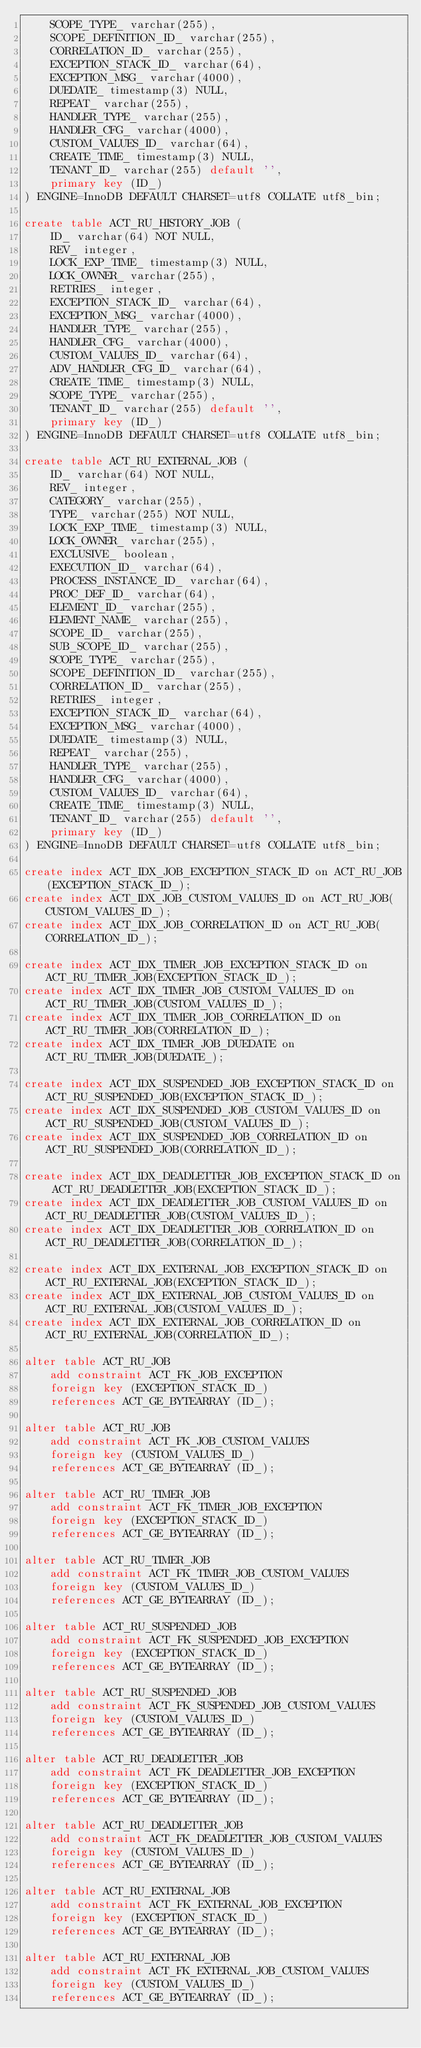Convert code to text. <code><loc_0><loc_0><loc_500><loc_500><_SQL_>    SCOPE_TYPE_ varchar(255),
    SCOPE_DEFINITION_ID_ varchar(255),
    CORRELATION_ID_ varchar(255),
    EXCEPTION_STACK_ID_ varchar(64),
    EXCEPTION_MSG_ varchar(4000),
    DUEDATE_ timestamp(3) NULL,
    REPEAT_ varchar(255),
    HANDLER_TYPE_ varchar(255),
    HANDLER_CFG_ varchar(4000),
    CUSTOM_VALUES_ID_ varchar(64),
    CREATE_TIME_ timestamp(3) NULL,
    TENANT_ID_ varchar(255) default '',
    primary key (ID_)
) ENGINE=InnoDB DEFAULT CHARSET=utf8 COLLATE utf8_bin;

create table ACT_RU_HISTORY_JOB (
    ID_ varchar(64) NOT NULL,
    REV_ integer,
    LOCK_EXP_TIME_ timestamp(3) NULL,
    LOCK_OWNER_ varchar(255),
    RETRIES_ integer,
    EXCEPTION_STACK_ID_ varchar(64),
    EXCEPTION_MSG_ varchar(4000),
    HANDLER_TYPE_ varchar(255),
    HANDLER_CFG_ varchar(4000),
    CUSTOM_VALUES_ID_ varchar(64),
    ADV_HANDLER_CFG_ID_ varchar(64),
    CREATE_TIME_ timestamp(3) NULL,
    SCOPE_TYPE_ varchar(255),
    TENANT_ID_ varchar(255) default '',
    primary key (ID_)
) ENGINE=InnoDB DEFAULT CHARSET=utf8 COLLATE utf8_bin;

create table ACT_RU_EXTERNAL_JOB (
    ID_ varchar(64) NOT NULL,
    REV_ integer,
    CATEGORY_ varchar(255),
    TYPE_ varchar(255) NOT NULL,
    LOCK_EXP_TIME_ timestamp(3) NULL,
    LOCK_OWNER_ varchar(255),
    EXCLUSIVE_ boolean,
    EXECUTION_ID_ varchar(64),
    PROCESS_INSTANCE_ID_ varchar(64),
    PROC_DEF_ID_ varchar(64),
    ELEMENT_ID_ varchar(255),
    ELEMENT_NAME_ varchar(255),
    SCOPE_ID_ varchar(255),
    SUB_SCOPE_ID_ varchar(255),
    SCOPE_TYPE_ varchar(255),
    SCOPE_DEFINITION_ID_ varchar(255),
    CORRELATION_ID_ varchar(255),
    RETRIES_ integer,
    EXCEPTION_STACK_ID_ varchar(64),
    EXCEPTION_MSG_ varchar(4000),
    DUEDATE_ timestamp(3) NULL,
    REPEAT_ varchar(255),
    HANDLER_TYPE_ varchar(255),
    HANDLER_CFG_ varchar(4000),
    CUSTOM_VALUES_ID_ varchar(64),
    CREATE_TIME_ timestamp(3) NULL,
    TENANT_ID_ varchar(255) default '',
    primary key (ID_)
) ENGINE=InnoDB DEFAULT CHARSET=utf8 COLLATE utf8_bin;

create index ACT_IDX_JOB_EXCEPTION_STACK_ID on ACT_RU_JOB(EXCEPTION_STACK_ID_);
create index ACT_IDX_JOB_CUSTOM_VALUES_ID on ACT_RU_JOB(CUSTOM_VALUES_ID_);
create index ACT_IDX_JOB_CORRELATION_ID on ACT_RU_JOB(CORRELATION_ID_);

create index ACT_IDX_TIMER_JOB_EXCEPTION_STACK_ID on ACT_RU_TIMER_JOB(EXCEPTION_STACK_ID_);
create index ACT_IDX_TIMER_JOB_CUSTOM_VALUES_ID on ACT_RU_TIMER_JOB(CUSTOM_VALUES_ID_);
create index ACT_IDX_TIMER_JOB_CORRELATION_ID on ACT_RU_TIMER_JOB(CORRELATION_ID_);
create index ACT_IDX_TIMER_JOB_DUEDATE on ACT_RU_TIMER_JOB(DUEDATE_); 

create index ACT_IDX_SUSPENDED_JOB_EXCEPTION_STACK_ID on ACT_RU_SUSPENDED_JOB(EXCEPTION_STACK_ID_);
create index ACT_IDX_SUSPENDED_JOB_CUSTOM_VALUES_ID on ACT_RU_SUSPENDED_JOB(CUSTOM_VALUES_ID_);
create index ACT_IDX_SUSPENDED_JOB_CORRELATION_ID on ACT_RU_SUSPENDED_JOB(CORRELATION_ID_);

create index ACT_IDX_DEADLETTER_JOB_EXCEPTION_STACK_ID on ACT_RU_DEADLETTER_JOB(EXCEPTION_STACK_ID_);
create index ACT_IDX_DEADLETTER_JOB_CUSTOM_VALUES_ID on ACT_RU_DEADLETTER_JOB(CUSTOM_VALUES_ID_);
create index ACT_IDX_DEADLETTER_JOB_CORRELATION_ID on ACT_RU_DEADLETTER_JOB(CORRELATION_ID_);

create index ACT_IDX_EXTERNAL_JOB_EXCEPTION_STACK_ID on ACT_RU_EXTERNAL_JOB(EXCEPTION_STACK_ID_);
create index ACT_IDX_EXTERNAL_JOB_CUSTOM_VALUES_ID on ACT_RU_EXTERNAL_JOB(CUSTOM_VALUES_ID_);
create index ACT_IDX_EXTERNAL_JOB_CORRELATION_ID on ACT_RU_EXTERNAL_JOB(CORRELATION_ID_);

alter table ACT_RU_JOB
    add constraint ACT_FK_JOB_EXCEPTION
    foreign key (EXCEPTION_STACK_ID_)
    references ACT_GE_BYTEARRAY (ID_);

alter table ACT_RU_JOB
    add constraint ACT_FK_JOB_CUSTOM_VALUES
    foreign key (CUSTOM_VALUES_ID_)
    references ACT_GE_BYTEARRAY (ID_);

alter table ACT_RU_TIMER_JOB
    add constraint ACT_FK_TIMER_JOB_EXCEPTION
    foreign key (EXCEPTION_STACK_ID_)
    references ACT_GE_BYTEARRAY (ID_);

alter table ACT_RU_TIMER_JOB
    add constraint ACT_FK_TIMER_JOB_CUSTOM_VALUES
    foreign key (CUSTOM_VALUES_ID_)
    references ACT_GE_BYTEARRAY (ID_);

alter table ACT_RU_SUSPENDED_JOB
    add constraint ACT_FK_SUSPENDED_JOB_EXCEPTION
    foreign key (EXCEPTION_STACK_ID_)
    references ACT_GE_BYTEARRAY (ID_);

alter table ACT_RU_SUSPENDED_JOB
    add constraint ACT_FK_SUSPENDED_JOB_CUSTOM_VALUES
    foreign key (CUSTOM_VALUES_ID_)
    references ACT_GE_BYTEARRAY (ID_);

alter table ACT_RU_DEADLETTER_JOB
    add constraint ACT_FK_DEADLETTER_JOB_EXCEPTION
    foreign key (EXCEPTION_STACK_ID_)
    references ACT_GE_BYTEARRAY (ID_);

alter table ACT_RU_DEADLETTER_JOB
    add constraint ACT_FK_DEADLETTER_JOB_CUSTOM_VALUES
    foreign key (CUSTOM_VALUES_ID_)
    references ACT_GE_BYTEARRAY (ID_);

alter table ACT_RU_EXTERNAL_JOB
    add constraint ACT_FK_EXTERNAL_JOB_EXCEPTION
    foreign key (EXCEPTION_STACK_ID_)
    references ACT_GE_BYTEARRAY (ID_);

alter table ACT_RU_EXTERNAL_JOB
    add constraint ACT_FK_EXTERNAL_JOB_CUSTOM_VALUES
    foreign key (CUSTOM_VALUES_ID_)
    references ACT_GE_BYTEARRAY (ID_);
</code> 